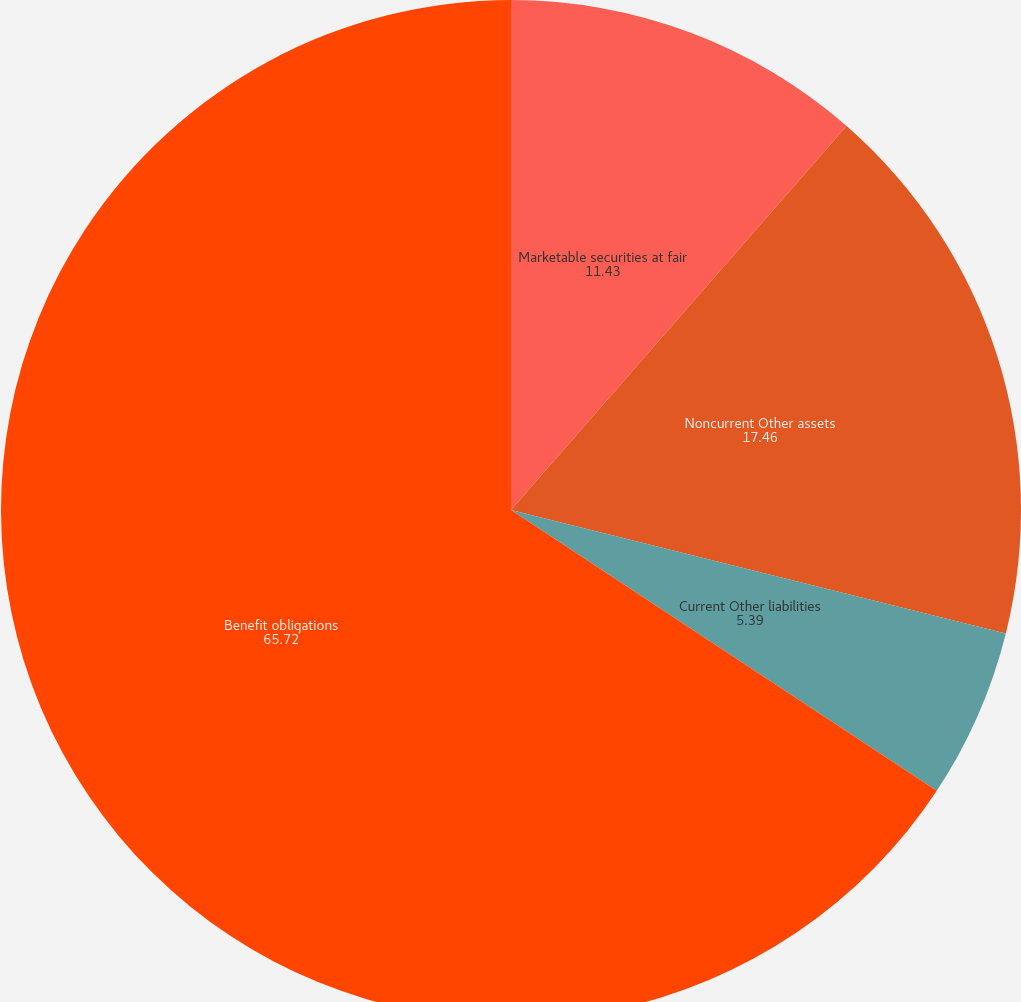Convert chart. <chart><loc_0><loc_0><loc_500><loc_500><pie_chart><fcel>Marketable securities at fair<fcel>Noncurrent Other assets<fcel>Current Other liabilities<fcel>Benefit obligations<nl><fcel>11.43%<fcel>17.46%<fcel>5.39%<fcel>65.72%<nl></chart> 